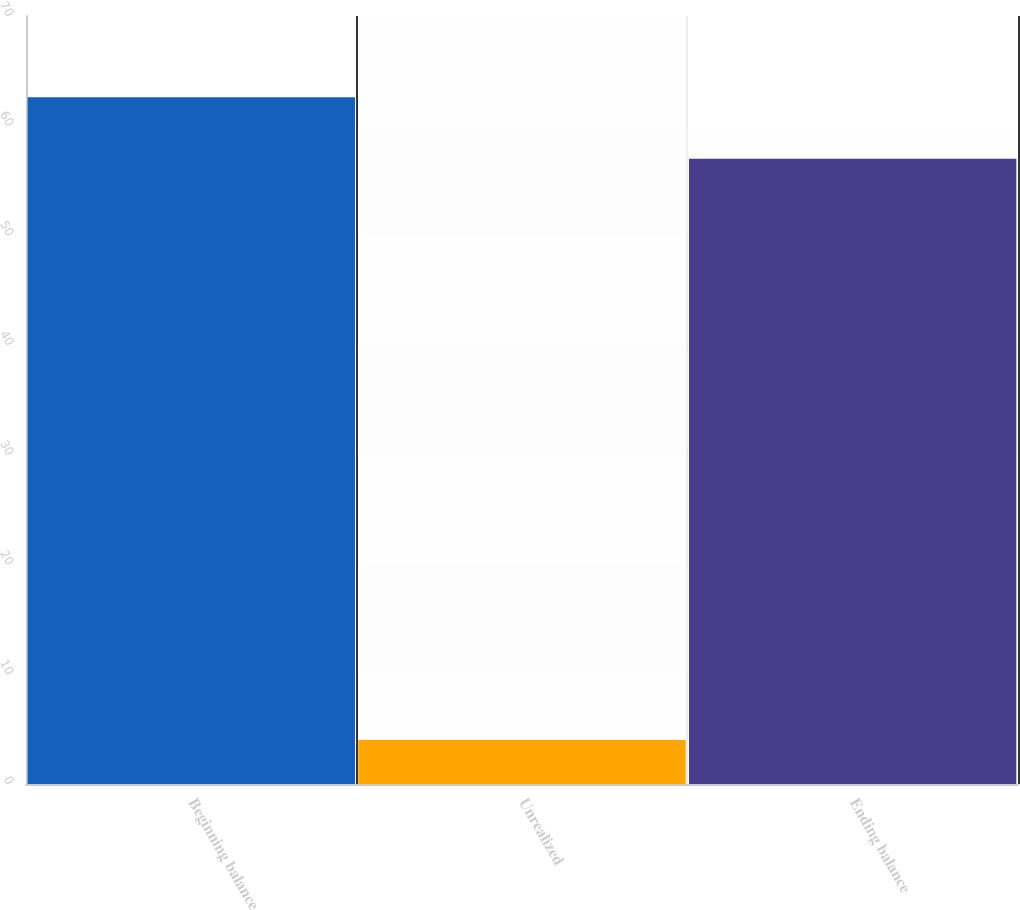Convert chart. <chart><loc_0><loc_0><loc_500><loc_500><bar_chart><fcel>Beginning balance<fcel>Unrealized<fcel>Ending balance<nl><fcel>62.6<fcel>4<fcel>57<nl></chart> 